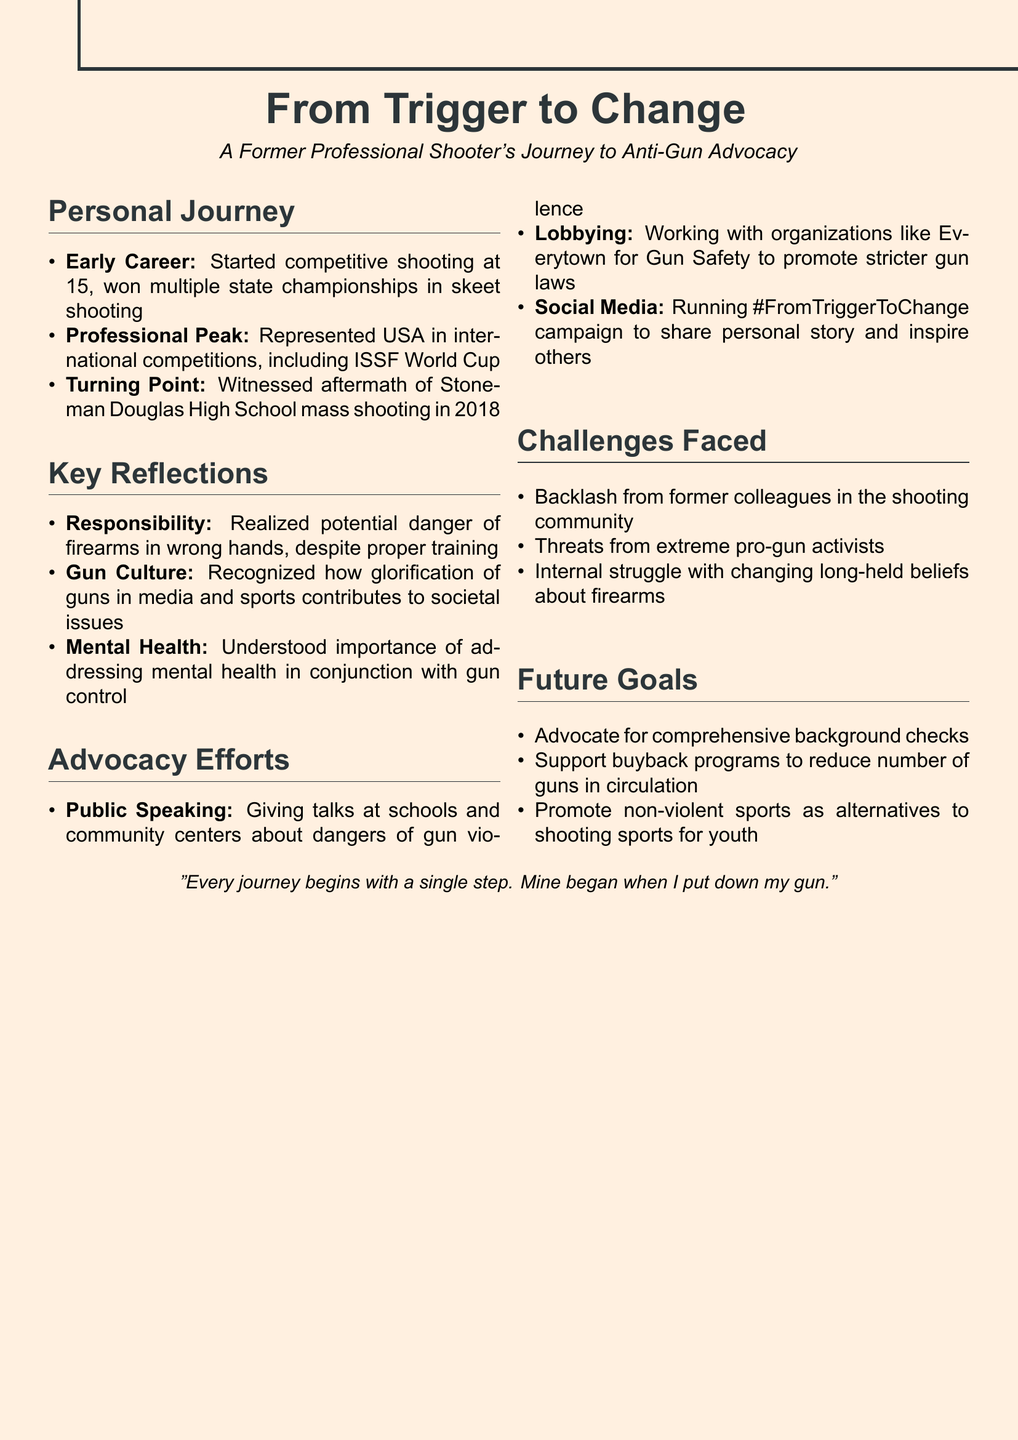What age did the individual start competitive shooting? The individual started competitive shooting at age 15, as stated in the Early Career section.
Answer: 15 Which high school event was a turning point for the individual? The turning point was witnessing the aftermath of the mass shooting at Stoneman Douglas High School in 2018.
Answer: Stoneman Douglas High School Name one initiative the individual is involved in for advocacy. One of the advocacy initiatives mentioned in the document is public speaking at schools and community centers.
Answer: Public Speaking What realization did the individual have regarding firearms? The individual realized the potential danger of firearms in the wrong hands, despite proper training.
Answer: Potential danger of firearms What is one future goal mentioned in the document? One future goal is to advocate for comprehensive background checks.
Answer: Comprehensive background checks What type of backlash did the individual face? The individual faced backlash from former colleagues in the shooting community.
Answer: Backlash from former colleagues Who does the individual work with for lobbying efforts? The individual works with organizations like Everytown for Gun Safety to promote stricter gun laws.
Answer: Everytown for Gun Safety What campaign is the individual running on social media? The individual is running the #FromTriggerToChange campaign to share their personal story.
Answer: #FromTriggerToChange 